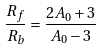<formula> <loc_0><loc_0><loc_500><loc_500>\frac { R _ { f } } { R _ { b } } = \frac { 2 A _ { 0 } + 3 } { A _ { 0 } - 3 }</formula> 